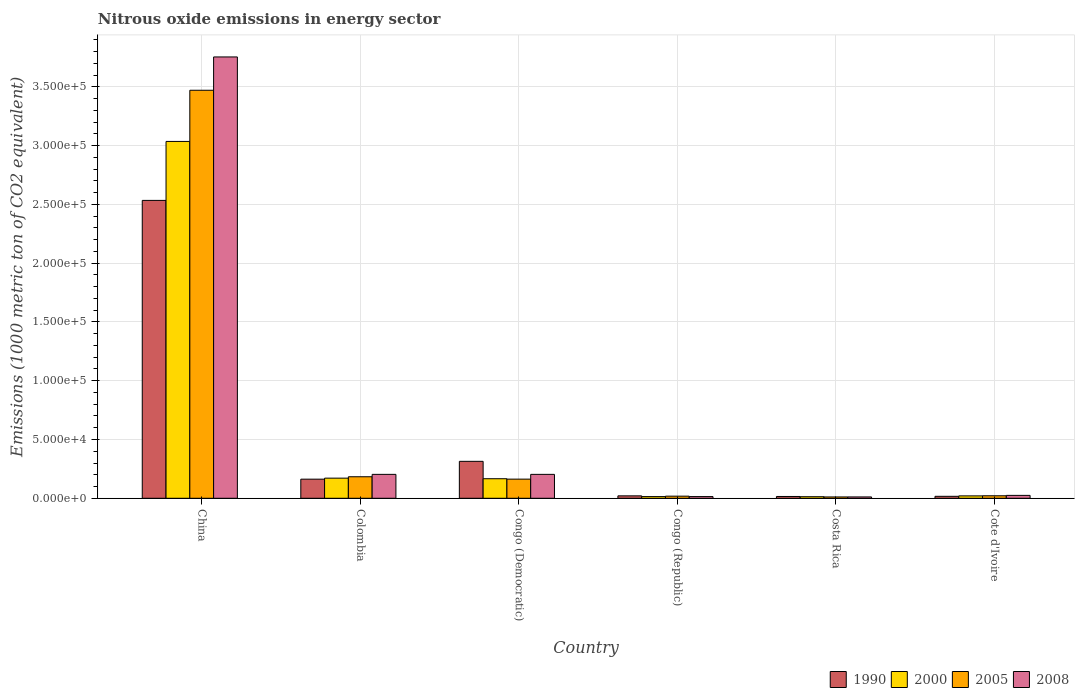How many different coloured bars are there?
Offer a terse response. 4. How many groups of bars are there?
Offer a terse response. 6. Are the number of bars on each tick of the X-axis equal?
Offer a terse response. Yes. How many bars are there on the 3rd tick from the left?
Your answer should be compact. 4. How many bars are there on the 4th tick from the right?
Offer a very short reply. 4. What is the label of the 2nd group of bars from the left?
Provide a short and direct response. Colombia. What is the amount of nitrous oxide emitted in 2000 in Congo (Republic)?
Provide a short and direct response. 1432.4. Across all countries, what is the maximum amount of nitrous oxide emitted in 2008?
Make the answer very short. 3.75e+05. Across all countries, what is the minimum amount of nitrous oxide emitted in 1990?
Make the answer very short. 1535. What is the total amount of nitrous oxide emitted in 1990 in the graph?
Your response must be concise. 3.06e+05. What is the difference between the amount of nitrous oxide emitted in 2005 in China and that in Costa Rica?
Keep it short and to the point. 3.46e+05. What is the difference between the amount of nitrous oxide emitted in 2005 in China and the amount of nitrous oxide emitted in 2000 in Costa Rica?
Ensure brevity in your answer.  3.46e+05. What is the average amount of nitrous oxide emitted in 1990 per country?
Your answer should be compact. 5.11e+04. What is the difference between the amount of nitrous oxide emitted of/in 2000 and amount of nitrous oxide emitted of/in 1990 in Colombia?
Provide a short and direct response. 864.4. In how many countries, is the amount of nitrous oxide emitted in 1990 greater than 130000 1000 metric ton?
Your answer should be compact. 1. What is the ratio of the amount of nitrous oxide emitted in 2008 in China to that in Colombia?
Ensure brevity in your answer.  18.46. What is the difference between the highest and the second highest amount of nitrous oxide emitted in 1990?
Your answer should be very brief. 2.22e+05. What is the difference between the highest and the lowest amount of nitrous oxide emitted in 2000?
Provide a short and direct response. 3.02e+05. Is it the case that in every country, the sum of the amount of nitrous oxide emitted in 2005 and amount of nitrous oxide emitted in 1990 is greater than the sum of amount of nitrous oxide emitted in 2008 and amount of nitrous oxide emitted in 2000?
Provide a short and direct response. No. How many bars are there?
Provide a short and direct response. 24. How many countries are there in the graph?
Ensure brevity in your answer.  6. Does the graph contain any zero values?
Your answer should be compact. No. How are the legend labels stacked?
Offer a very short reply. Horizontal. What is the title of the graph?
Provide a succinct answer. Nitrous oxide emissions in energy sector. What is the label or title of the X-axis?
Provide a short and direct response. Country. What is the label or title of the Y-axis?
Ensure brevity in your answer.  Emissions (1000 metric ton of CO2 equivalent). What is the Emissions (1000 metric ton of CO2 equivalent) of 1990 in China?
Offer a terse response. 2.53e+05. What is the Emissions (1000 metric ton of CO2 equivalent) of 2000 in China?
Ensure brevity in your answer.  3.04e+05. What is the Emissions (1000 metric ton of CO2 equivalent) of 2005 in China?
Make the answer very short. 3.47e+05. What is the Emissions (1000 metric ton of CO2 equivalent) in 2008 in China?
Provide a short and direct response. 3.75e+05. What is the Emissions (1000 metric ton of CO2 equivalent) of 1990 in Colombia?
Give a very brief answer. 1.63e+04. What is the Emissions (1000 metric ton of CO2 equivalent) of 2000 in Colombia?
Your answer should be very brief. 1.71e+04. What is the Emissions (1000 metric ton of CO2 equivalent) in 2005 in Colombia?
Offer a terse response. 1.83e+04. What is the Emissions (1000 metric ton of CO2 equivalent) of 2008 in Colombia?
Keep it short and to the point. 2.03e+04. What is the Emissions (1000 metric ton of CO2 equivalent) of 1990 in Congo (Democratic)?
Your response must be concise. 3.14e+04. What is the Emissions (1000 metric ton of CO2 equivalent) of 2000 in Congo (Democratic)?
Make the answer very short. 1.66e+04. What is the Emissions (1000 metric ton of CO2 equivalent) of 2005 in Congo (Democratic)?
Your response must be concise. 1.63e+04. What is the Emissions (1000 metric ton of CO2 equivalent) of 2008 in Congo (Democratic)?
Keep it short and to the point. 2.03e+04. What is the Emissions (1000 metric ton of CO2 equivalent) of 1990 in Congo (Republic)?
Provide a succinct answer. 2061.2. What is the Emissions (1000 metric ton of CO2 equivalent) in 2000 in Congo (Republic)?
Keep it short and to the point. 1432.4. What is the Emissions (1000 metric ton of CO2 equivalent) of 2005 in Congo (Republic)?
Your answer should be very brief. 1806.4. What is the Emissions (1000 metric ton of CO2 equivalent) of 2008 in Congo (Republic)?
Provide a short and direct response. 1443.1. What is the Emissions (1000 metric ton of CO2 equivalent) in 1990 in Costa Rica?
Provide a short and direct response. 1535. What is the Emissions (1000 metric ton of CO2 equivalent) in 2000 in Costa Rica?
Offer a terse response. 1331.8. What is the Emissions (1000 metric ton of CO2 equivalent) of 2005 in Costa Rica?
Ensure brevity in your answer.  1138.2. What is the Emissions (1000 metric ton of CO2 equivalent) of 2008 in Costa Rica?
Keep it short and to the point. 1145.2. What is the Emissions (1000 metric ton of CO2 equivalent) in 1990 in Cote d'Ivoire?
Provide a succinct answer. 1664.9. What is the Emissions (1000 metric ton of CO2 equivalent) of 2000 in Cote d'Ivoire?
Ensure brevity in your answer.  2041.8. What is the Emissions (1000 metric ton of CO2 equivalent) in 2005 in Cote d'Ivoire?
Keep it short and to the point. 2128.3. What is the Emissions (1000 metric ton of CO2 equivalent) in 2008 in Cote d'Ivoire?
Ensure brevity in your answer.  2465.6. Across all countries, what is the maximum Emissions (1000 metric ton of CO2 equivalent) in 1990?
Keep it short and to the point. 2.53e+05. Across all countries, what is the maximum Emissions (1000 metric ton of CO2 equivalent) of 2000?
Offer a very short reply. 3.04e+05. Across all countries, what is the maximum Emissions (1000 metric ton of CO2 equivalent) of 2005?
Your answer should be very brief. 3.47e+05. Across all countries, what is the maximum Emissions (1000 metric ton of CO2 equivalent) of 2008?
Provide a succinct answer. 3.75e+05. Across all countries, what is the minimum Emissions (1000 metric ton of CO2 equivalent) in 1990?
Ensure brevity in your answer.  1535. Across all countries, what is the minimum Emissions (1000 metric ton of CO2 equivalent) of 2000?
Provide a succinct answer. 1331.8. Across all countries, what is the minimum Emissions (1000 metric ton of CO2 equivalent) in 2005?
Keep it short and to the point. 1138.2. Across all countries, what is the minimum Emissions (1000 metric ton of CO2 equivalent) of 2008?
Your response must be concise. 1145.2. What is the total Emissions (1000 metric ton of CO2 equivalent) of 1990 in the graph?
Your answer should be very brief. 3.06e+05. What is the total Emissions (1000 metric ton of CO2 equivalent) of 2000 in the graph?
Your answer should be compact. 3.42e+05. What is the total Emissions (1000 metric ton of CO2 equivalent) in 2005 in the graph?
Provide a short and direct response. 3.87e+05. What is the total Emissions (1000 metric ton of CO2 equivalent) in 2008 in the graph?
Your answer should be compact. 4.21e+05. What is the difference between the Emissions (1000 metric ton of CO2 equivalent) of 1990 in China and that in Colombia?
Offer a terse response. 2.37e+05. What is the difference between the Emissions (1000 metric ton of CO2 equivalent) in 2000 in China and that in Colombia?
Your response must be concise. 2.86e+05. What is the difference between the Emissions (1000 metric ton of CO2 equivalent) in 2005 in China and that in Colombia?
Your answer should be compact. 3.29e+05. What is the difference between the Emissions (1000 metric ton of CO2 equivalent) in 2008 in China and that in Colombia?
Ensure brevity in your answer.  3.55e+05. What is the difference between the Emissions (1000 metric ton of CO2 equivalent) of 1990 in China and that in Congo (Democratic)?
Your response must be concise. 2.22e+05. What is the difference between the Emissions (1000 metric ton of CO2 equivalent) of 2000 in China and that in Congo (Democratic)?
Ensure brevity in your answer.  2.87e+05. What is the difference between the Emissions (1000 metric ton of CO2 equivalent) of 2005 in China and that in Congo (Democratic)?
Make the answer very short. 3.31e+05. What is the difference between the Emissions (1000 metric ton of CO2 equivalent) of 2008 in China and that in Congo (Democratic)?
Your answer should be very brief. 3.55e+05. What is the difference between the Emissions (1000 metric ton of CO2 equivalent) of 1990 in China and that in Congo (Republic)?
Your response must be concise. 2.51e+05. What is the difference between the Emissions (1000 metric ton of CO2 equivalent) in 2000 in China and that in Congo (Republic)?
Provide a short and direct response. 3.02e+05. What is the difference between the Emissions (1000 metric ton of CO2 equivalent) in 2005 in China and that in Congo (Republic)?
Give a very brief answer. 3.45e+05. What is the difference between the Emissions (1000 metric ton of CO2 equivalent) in 2008 in China and that in Congo (Republic)?
Ensure brevity in your answer.  3.74e+05. What is the difference between the Emissions (1000 metric ton of CO2 equivalent) in 1990 in China and that in Costa Rica?
Provide a short and direct response. 2.52e+05. What is the difference between the Emissions (1000 metric ton of CO2 equivalent) of 2000 in China and that in Costa Rica?
Provide a short and direct response. 3.02e+05. What is the difference between the Emissions (1000 metric ton of CO2 equivalent) in 2005 in China and that in Costa Rica?
Keep it short and to the point. 3.46e+05. What is the difference between the Emissions (1000 metric ton of CO2 equivalent) of 2008 in China and that in Costa Rica?
Your answer should be compact. 3.74e+05. What is the difference between the Emissions (1000 metric ton of CO2 equivalent) in 1990 in China and that in Cote d'Ivoire?
Your answer should be compact. 2.52e+05. What is the difference between the Emissions (1000 metric ton of CO2 equivalent) of 2000 in China and that in Cote d'Ivoire?
Keep it short and to the point. 3.02e+05. What is the difference between the Emissions (1000 metric ton of CO2 equivalent) in 2005 in China and that in Cote d'Ivoire?
Offer a terse response. 3.45e+05. What is the difference between the Emissions (1000 metric ton of CO2 equivalent) in 2008 in China and that in Cote d'Ivoire?
Your answer should be very brief. 3.73e+05. What is the difference between the Emissions (1000 metric ton of CO2 equivalent) in 1990 in Colombia and that in Congo (Democratic)?
Keep it short and to the point. -1.52e+04. What is the difference between the Emissions (1000 metric ton of CO2 equivalent) in 2000 in Colombia and that in Congo (Democratic)?
Keep it short and to the point. 489.3. What is the difference between the Emissions (1000 metric ton of CO2 equivalent) of 2005 in Colombia and that in Congo (Democratic)?
Keep it short and to the point. 2014.7. What is the difference between the Emissions (1000 metric ton of CO2 equivalent) of 1990 in Colombia and that in Congo (Republic)?
Your answer should be very brief. 1.42e+04. What is the difference between the Emissions (1000 metric ton of CO2 equivalent) in 2000 in Colombia and that in Congo (Republic)?
Keep it short and to the point. 1.57e+04. What is the difference between the Emissions (1000 metric ton of CO2 equivalent) in 2005 in Colombia and that in Congo (Republic)?
Offer a terse response. 1.65e+04. What is the difference between the Emissions (1000 metric ton of CO2 equivalent) in 2008 in Colombia and that in Congo (Republic)?
Offer a very short reply. 1.89e+04. What is the difference between the Emissions (1000 metric ton of CO2 equivalent) of 1990 in Colombia and that in Costa Rica?
Provide a short and direct response. 1.47e+04. What is the difference between the Emissions (1000 metric ton of CO2 equivalent) in 2000 in Colombia and that in Costa Rica?
Your answer should be very brief. 1.58e+04. What is the difference between the Emissions (1000 metric ton of CO2 equivalent) in 2005 in Colombia and that in Costa Rica?
Offer a terse response. 1.72e+04. What is the difference between the Emissions (1000 metric ton of CO2 equivalent) in 2008 in Colombia and that in Costa Rica?
Provide a succinct answer. 1.92e+04. What is the difference between the Emissions (1000 metric ton of CO2 equivalent) in 1990 in Colombia and that in Cote d'Ivoire?
Make the answer very short. 1.46e+04. What is the difference between the Emissions (1000 metric ton of CO2 equivalent) of 2000 in Colombia and that in Cote d'Ivoire?
Your answer should be compact. 1.51e+04. What is the difference between the Emissions (1000 metric ton of CO2 equivalent) in 2005 in Colombia and that in Cote d'Ivoire?
Make the answer very short. 1.62e+04. What is the difference between the Emissions (1000 metric ton of CO2 equivalent) in 2008 in Colombia and that in Cote d'Ivoire?
Ensure brevity in your answer.  1.79e+04. What is the difference between the Emissions (1000 metric ton of CO2 equivalent) in 1990 in Congo (Democratic) and that in Congo (Republic)?
Provide a succinct answer. 2.94e+04. What is the difference between the Emissions (1000 metric ton of CO2 equivalent) of 2000 in Congo (Democratic) and that in Congo (Republic)?
Make the answer very short. 1.52e+04. What is the difference between the Emissions (1000 metric ton of CO2 equivalent) in 2005 in Congo (Democratic) and that in Congo (Republic)?
Your answer should be very brief. 1.45e+04. What is the difference between the Emissions (1000 metric ton of CO2 equivalent) of 2008 in Congo (Democratic) and that in Congo (Republic)?
Provide a succinct answer. 1.89e+04. What is the difference between the Emissions (1000 metric ton of CO2 equivalent) in 1990 in Congo (Democratic) and that in Costa Rica?
Give a very brief answer. 2.99e+04. What is the difference between the Emissions (1000 metric ton of CO2 equivalent) in 2000 in Congo (Democratic) and that in Costa Rica?
Your response must be concise. 1.53e+04. What is the difference between the Emissions (1000 metric ton of CO2 equivalent) of 2005 in Congo (Democratic) and that in Costa Rica?
Ensure brevity in your answer.  1.52e+04. What is the difference between the Emissions (1000 metric ton of CO2 equivalent) in 2008 in Congo (Democratic) and that in Costa Rica?
Keep it short and to the point. 1.92e+04. What is the difference between the Emissions (1000 metric ton of CO2 equivalent) of 1990 in Congo (Democratic) and that in Cote d'Ivoire?
Your answer should be very brief. 2.98e+04. What is the difference between the Emissions (1000 metric ton of CO2 equivalent) of 2000 in Congo (Democratic) and that in Cote d'Ivoire?
Offer a very short reply. 1.46e+04. What is the difference between the Emissions (1000 metric ton of CO2 equivalent) of 2005 in Congo (Democratic) and that in Cote d'Ivoire?
Keep it short and to the point. 1.42e+04. What is the difference between the Emissions (1000 metric ton of CO2 equivalent) in 2008 in Congo (Democratic) and that in Cote d'Ivoire?
Your answer should be very brief. 1.79e+04. What is the difference between the Emissions (1000 metric ton of CO2 equivalent) in 1990 in Congo (Republic) and that in Costa Rica?
Provide a succinct answer. 526.2. What is the difference between the Emissions (1000 metric ton of CO2 equivalent) in 2000 in Congo (Republic) and that in Costa Rica?
Your answer should be compact. 100.6. What is the difference between the Emissions (1000 metric ton of CO2 equivalent) in 2005 in Congo (Republic) and that in Costa Rica?
Keep it short and to the point. 668.2. What is the difference between the Emissions (1000 metric ton of CO2 equivalent) in 2008 in Congo (Republic) and that in Costa Rica?
Provide a short and direct response. 297.9. What is the difference between the Emissions (1000 metric ton of CO2 equivalent) in 1990 in Congo (Republic) and that in Cote d'Ivoire?
Offer a very short reply. 396.3. What is the difference between the Emissions (1000 metric ton of CO2 equivalent) in 2000 in Congo (Republic) and that in Cote d'Ivoire?
Provide a short and direct response. -609.4. What is the difference between the Emissions (1000 metric ton of CO2 equivalent) of 2005 in Congo (Republic) and that in Cote d'Ivoire?
Keep it short and to the point. -321.9. What is the difference between the Emissions (1000 metric ton of CO2 equivalent) of 2008 in Congo (Republic) and that in Cote d'Ivoire?
Provide a short and direct response. -1022.5. What is the difference between the Emissions (1000 metric ton of CO2 equivalent) in 1990 in Costa Rica and that in Cote d'Ivoire?
Provide a short and direct response. -129.9. What is the difference between the Emissions (1000 metric ton of CO2 equivalent) in 2000 in Costa Rica and that in Cote d'Ivoire?
Keep it short and to the point. -710. What is the difference between the Emissions (1000 metric ton of CO2 equivalent) of 2005 in Costa Rica and that in Cote d'Ivoire?
Provide a succinct answer. -990.1. What is the difference between the Emissions (1000 metric ton of CO2 equivalent) of 2008 in Costa Rica and that in Cote d'Ivoire?
Offer a terse response. -1320.4. What is the difference between the Emissions (1000 metric ton of CO2 equivalent) of 1990 in China and the Emissions (1000 metric ton of CO2 equivalent) of 2000 in Colombia?
Provide a succinct answer. 2.36e+05. What is the difference between the Emissions (1000 metric ton of CO2 equivalent) of 1990 in China and the Emissions (1000 metric ton of CO2 equivalent) of 2005 in Colombia?
Offer a very short reply. 2.35e+05. What is the difference between the Emissions (1000 metric ton of CO2 equivalent) of 1990 in China and the Emissions (1000 metric ton of CO2 equivalent) of 2008 in Colombia?
Offer a very short reply. 2.33e+05. What is the difference between the Emissions (1000 metric ton of CO2 equivalent) of 2000 in China and the Emissions (1000 metric ton of CO2 equivalent) of 2005 in Colombia?
Make the answer very short. 2.85e+05. What is the difference between the Emissions (1000 metric ton of CO2 equivalent) of 2000 in China and the Emissions (1000 metric ton of CO2 equivalent) of 2008 in Colombia?
Offer a terse response. 2.83e+05. What is the difference between the Emissions (1000 metric ton of CO2 equivalent) of 2005 in China and the Emissions (1000 metric ton of CO2 equivalent) of 2008 in Colombia?
Your response must be concise. 3.27e+05. What is the difference between the Emissions (1000 metric ton of CO2 equivalent) in 1990 in China and the Emissions (1000 metric ton of CO2 equivalent) in 2000 in Congo (Democratic)?
Your answer should be compact. 2.37e+05. What is the difference between the Emissions (1000 metric ton of CO2 equivalent) of 1990 in China and the Emissions (1000 metric ton of CO2 equivalent) of 2005 in Congo (Democratic)?
Keep it short and to the point. 2.37e+05. What is the difference between the Emissions (1000 metric ton of CO2 equivalent) in 1990 in China and the Emissions (1000 metric ton of CO2 equivalent) in 2008 in Congo (Democratic)?
Offer a very short reply. 2.33e+05. What is the difference between the Emissions (1000 metric ton of CO2 equivalent) of 2000 in China and the Emissions (1000 metric ton of CO2 equivalent) of 2005 in Congo (Democratic)?
Provide a short and direct response. 2.87e+05. What is the difference between the Emissions (1000 metric ton of CO2 equivalent) of 2000 in China and the Emissions (1000 metric ton of CO2 equivalent) of 2008 in Congo (Democratic)?
Ensure brevity in your answer.  2.83e+05. What is the difference between the Emissions (1000 metric ton of CO2 equivalent) of 2005 in China and the Emissions (1000 metric ton of CO2 equivalent) of 2008 in Congo (Democratic)?
Your response must be concise. 3.27e+05. What is the difference between the Emissions (1000 metric ton of CO2 equivalent) in 1990 in China and the Emissions (1000 metric ton of CO2 equivalent) in 2000 in Congo (Republic)?
Your answer should be very brief. 2.52e+05. What is the difference between the Emissions (1000 metric ton of CO2 equivalent) of 1990 in China and the Emissions (1000 metric ton of CO2 equivalent) of 2005 in Congo (Republic)?
Provide a succinct answer. 2.52e+05. What is the difference between the Emissions (1000 metric ton of CO2 equivalent) of 1990 in China and the Emissions (1000 metric ton of CO2 equivalent) of 2008 in Congo (Republic)?
Offer a terse response. 2.52e+05. What is the difference between the Emissions (1000 metric ton of CO2 equivalent) of 2000 in China and the Emissions (1000 metric ton of CO2 equivalent) of 2005 in Congo (Republic)?
Your answer should be very brief. 3.02e+05. What is the difference between the Emissions (1000 metric ton of CO2 equivalent) of 2000 in China and the Emissions (1000 metric ton of CO2 equivalent) of 2008 in Congo (Republic)?
Provide a short and direct response. 3.02e+05. What is the difference between the Emissions (1000 metric ton of CO2 equivalent) of 2005 in China and the Emissions (1000 metric ton of CO2 equivalent) of 2008 in Congo (Republic)?
Keep it short and to the point. 3.46e+05. What is the difference between the Emissions (1000 metric ton of CO2 equivalent) of 1990 in China and the Emissions (1000 metric ton of CO2 equivalent) of 2000 in Costa Rica?
Make the answer very short. 2.52e+05. What is the difference between the Emissions (1000 metric ton of CO2 equivalent) in 1990 in China and the Emissions (1000 metric ton of CO2 equivalent) in 2005 in Costa Rica?
Your answer should be compact. 2.52e+05. What is the difference between the Emissions (1000 metric ton of CO2 equivalent) in 1990 in China and the Emissions (1000 metric ton of CO2 equivalent) in 2008 in Costa Rica?
Your answer should be very brief. 2.52e+05. What is the difference between the Emissions (1000 metric ton of CO2 equivalent) in 2000 in China and the Emissions (1000 metric ton of CO2 equivalent) in 2005 in Costa Rica?
Give a very brief answer. 3.02e+05. What is the difference between the Emissions (1000 metric ton of CO2 equivalent) in 2000 in China and the Emissions (1000 metric ton of CO2 equivalent) in 2008 in Costa Rica?
Your response must be concise. 3.02e+05. What is the difference between the Emissions (1000 metric ton of CO2 equivalent) in 2005 in China and the Emissions (1000 metric ton of CO2 equivalent) in 2008 in Costa Rica?
Ensure brevity in your answer.  3.46e+05. What is the difference between the Emissions (1000 metric ton of CO2 equivalent) of 1990 in China and the Emissions (1000 metric ton of CO2 equivalent) of 2000 in Cote d'Ivoire?
Keep it short and to the point. 2.51e+05. What is the difference between the Emissions (1000 metric ton of CO2 equivalent) in 1990 in China and the Emissions (1000 metric ton of CO2 equivalent) in 2005 in Cote d'Ivoire?
Provide a succinct answer. 2.51e+05. What is the difference between the Emissions (1000 metric ton of CO2 equivalent) of 1990 in China and the Emissions (1000 metric ton of CO2 equivalent) of 2008 in Cote d'Ivoire?
Give a very brief answer. 2.51e+05. What is the difference between the Emissions (1000 metric ton of CO2 equivalent) in 2000 in China and the Emissions (1000 metric ton of CO2 equivalent) in 2005 in Cote d'Ivoire?
Make the answer very short. 3.01e+05. What is the difference between the Emissions (1000 metric ton of CO2 equivalent) in 2000 in China and the Emissions (1000 metric ton of CO2 equivalent) in 2008 in Cote d'Ivoire?
Ensure brevity in your answer.  3.01e+05. What is the difference between the Emissions (1000 metric ton of CO2 equivalent) in 2005 in China and the Emissions (1000 metric ton of CO2 equivalent) in 2008 in Cote d'Ivoire?
Your answer should be compact. 3.45e+05. What is the difference between the Emissions (1000 metric ton of CO2 equivalent) of 1990 in Colombia and the Emissions (1000 metric ton of CO2 equivalent) of 2000 in Congo (Democratic)?
Offer a very short reply. -375.1. What is the difference between the Emissions (1000 metric ton of CO2 equivalent) in 1990 in Colombia and the Emissions (1000 metric ton of CO2 equivalent) in 2005 in Congo (Democratic)?
Make the answer very short. -32.9. What is the difference between the Emissions (1000 metric ton of CO2 equivalent) in 1990 in Colombia and the Emissions (1000 metric ton of CO2 equivalent) in 2008 in Congo (Democratic)?
Offer a very short reply. -4075.6. What is the difference between the Emissions (1000 metric ton of CO2 equivalent) in 2000 in Colombia and the Emissions (1000 metric ton of CO2 equivalent) in 2005 in Congo (Democratic)?
Your answer should be very brief. 831.5. What is the difference between the Emissions (1000 metric ton of CO2 equivalent) in 2000 in Colombia and the Emissions (1000 metric ton of CO2 equivalent) in 2008 in Congo (Democratic)?
Provide a short and direct response. -3211.2. What is the difference between the Emissions (1000 metric ton of CO2 equivalent) in 2005 in Colombia and the Emissions (1000 metric ton of CO2 equivalent) in 2008 in Congo (Democratic)?
Your answer should be compact. -2028. What is the difference between the Emissions (1000 metric ton of CO2 equivalent) of 1990 in Colombia and the Emissions (1000 metric ton of CO2 equivalent) of 2000 in Congo (Republic)?
Provide a short and direct response. 1.48e+04. What is the difference between the Emissions (1000 metric ton of CO2 equivalent) in 1990 in Colombia and the Emissions (1000 metric ton of CO2 equivalent) in 2005 in Congo (Republic)?
Provide a succinct answer. 1.45e+04. What is the difference between the Emissions (1000 metric ton of CO2 equivalent) in 1990 in Colombia and the Emissions (1000 metric ton of CO2 equivalent) in 2008 in Congo (Republic)?
Provide a short and direct response. 1.48e+04. What is the difference between the Emissions (1000 metric ton of CO2 equivalent) of 2000 in Colombia and the Emissions (1000 metric ton of CO2 equivalent) of 2005 in Congo (Republic)?
Provide a short and direct response. 1.53e+04. What is the difference between the Emissions (1000 metric ton of CO2 equivalent) in 2000 in Colombia and the Emissions (1000 metric ton of CO2 equivalent) in 2008 in Congo (Republic)?
Your answer should be very brief. 1.57e+04. What is the difference between the Emissions (1000 metric ton of CO2 equivalent) of 2005 in Colombia and the Emissions (1000 metric ton of CO2 equivalent) of 2008 in Congo (Republic)?
Provide a succinct answer. 1.69e+04. What is the difference between the Emissions (1000 metric ton of CO2 equivalent) in 1990 in Colombia and the Emissions (1000 metric ton of CO2 equivalent) in 2000 in Costa Rica?
Offer a terse response. 1.49e+04. What is the difference between the Emissions (1000 metric ton of CO2 equivalent) in 1990 in Colombia and the Emissions (1000 metric ton of CO2 equivalent) in 2005 in Costa Rica?
Give a very brief answer. 1.51e+04. What is the difference between the Emissions (1000 metric ton of CO2 equivalent) of 1990 in Colombia and the Emissions (1000 metric ton of CO2 equivalent) of 2008 in Costa Rica?
Provide a short and direct response. 1.51e+04. What is the difference between the Emissions (1000 metric ton of CO2 equivalent) of 2000 in Colombia and the Emissions (1000 metric ton of CO2 equivalent) of 2005 in Costa Rica?
Offer a terse response. 1.60e+04. What is the difference between the Emissions (1000 metric ton of CO2 equivalent) in 2000 in Colombia and the Emissions (1000 metric ton of CO2 equivalent) in 2008 in Costa Rica?
Give a very brief answer. 1.60e+04. What is the difference between the Emissions (1000 metric ton of CO2 equivalent) in 2005 in Colombia and the Emissions (1000 metric ton of CO2 equivalent) in 2008 in Costa Rica?
Ensure brevity in your answer.  1.72e+04. What is the difference between the Emissions (1000 metric ton of CO2 equivalent) of 1990 in Colombia and the Emissions (1000 metric ton of CO2 equivalent) of 2000 in Cote d'Ivoire?
Your response must be concise. 1.42e+04. What is the difference between the Emissions (1000 metric ton of CO2 equivalent) of 1990 in Colombia and the Emissions (1000 metric ton of CO2 equivalent) of 2005 in Cote d'Ivoire?
Provide a short and direct response. 1.41e+04. What is the difference between the Emissions (1000 metric ton of CO2 equivalent) of 1990 in Colombia and the Emissions (1000 metric ton of CO2 equivalent) of 2008 in Cote d'Ivoire?
Your answer should be compact. 1.38e+04. What is the difference between the Emissions (1000 metric ton of CO2 equivalent) in 2000 in Colombia and the Emissions (1000 metric ton of CO2 equivalent) in 2005 in Cote d'Ivoire?
Offer a very short reply. 1.50e+04. What is the difference between the Emissions (1000 metric ton of CO2 equivalent) of 2000 in Colombia and the Emissions (1000 metric ton of CO2 equivalent) of 2008 in Cote d'Ivoire?
Provide a short and direct response. 1.47e+04. What is the difference between the Emissions (1000 metric ton of CO2 equivalent) in 2005 in Colombia and the Emissions (1000 metric ton of CO2 equivalent) in 2008 in Cote d'Ivoire?
Give a very brief answer. 1.58e+04. What is the difference between the Emissions (1000 metric ton of CO2 equivalent) in 1990 in Congo (Democratic) and the Emissions (1000 metric ton of CO2 equivalent) in 2000 in Congo (Republic)?
Ensure brevity in your answer.  3.00e+04. What is the difference between the Emissions (1000 metric ton of CO2 equivalent) of 1990 in Congo (Democratic) and the Emissions (1000 metric ton of CO2 equivalent) of 2005 in Congo (Republic)?
Ensure brevity in your answer.  2.96e+04. What is the difference between the Emissions (1000 metric ton of CO2 equivalent) of 1990 in Congo (Democratic) and the Emissions (1000 metric ton of CO2 equivalent) of 2008 in Congo (Republic)?
Provide a short and direct response. 3.00e+04. What is the difference between the Emissions (1000 metric ton of CO2 equivalent) in 2000 in Congo (Democratic) and the Emissions (1000 metric ton of CO2 equivalent) in 2005 in Congo (Republic)?
Provide a succinct answer. 1.48e+04. What is the difference between the Emissions (1000 metric ton of CO2 equivalent) of 2000 in Congo (Democratic) and the Emissions (1000 metric ton of CO2 equivalent) of 2008 in Congo (Republic)?
Give a very brief answer. 1.52e+04. What is the difference between the Emissions (1000 metric ton of CO2 equivalent) in 2005 in Congo (Democratic) and the Emissions (1000 metric ton of CO2 equivalent) in 2008 in Congo (Republic)?
Offer a terse response. 1.49e+04. What is the difference between the Emissions (1000 metric ton of CO2 equivalent) of 1990 in Congo (Democratic) and the Emissions (1000 metric ton of CO2 equivalent) of 2000 in Costa Rica?
Your answer should be very brief. 3.01e+04. What is the difference between the Emissions (1000 metric ton of CO2 equivalent) in 1990 in Congo (Democratic) and the Emissions (1000 metric ton of CO2 equivalent) in 2005 in Costa Rica?
Make the answer very short. 3.03e+04. What is the difference between the Emissions (1000 metric ton of CO2 equivalent) in 1990 in Congo (Democratic) and the Emissions (1000 metric ton of CO2 equivalent) in 2008 in Costa Rica?
Your answer should be compact. 3.03e+04. What is the difference between the Emissions (1000 metric ton of CO2 equivalent) in 2000 in Congo (Democratic) and the Emissions (1000 metric ton of CO2 equivalent) in 2005 in Costa Rica?
Provide a succinct answer. 1.55e+04. What is the difference between the Emissions (1000 metric ton of CO2 equivalent) in 2000 in Congo (Democratic) and the Emissions (1000 metric ton of CO2 equivalent) in 2008 in Costa Rica?
Make the answer very short. 1.55e+04. What is the difference between the Emissions (1000 metric ton of CO2 equivalent) of 2005 in Congo (Democratic) and the Emissions (1000 metric ton of CO2 equivalent) of 2008 in Costa Rica?
Make the answer very short. 1.51e+04. What is the difference between the Emissions (1000 metric ton of CO2 equivalent) in 1990 in Congo (Democratic) and the Emissions (1000 metric ton of CO2 equivalent) in 2000 in Cote d'Ivoire?
Offer a very short reply. 2.94e+04. What is the difference between the Emissions (1000 metric ton of CO2 equivalent) in 1990 in Congo (Democratic) and the Emissions (1000 metric ton of CO2 equivalent) in 2005 in Cote d'Ivoire?
Give a very brief answer. 2.93e+04. What is the difference between the Emissions (1000 metric ton of CO2 equivalent) in 1990 in Congo (Democratic) and the Emissions (1000 metric ton of CO2 equivalent) in 2008 in Cote d'Ivoire?
Your answer should be compact. 2.90e+04. What is the difference between the Emissions (1000 metric ton of CO2 equivalent) of 2000 in Congo (Democratic) and the Emissions (1000 metric ton of CO2 equivalent) of 2005 in Cote d'Ivoire?
Provide a succinct answer. 1.45e+04. What is the difference between the Emissions (1000 metric ton of CO2 equivalent) in 2000 in Congo (Democratic) and the Emissions (1000 metric ton of CO2 equivalent) in 2008 in Cote d'Ivoire?
Provide a short and direct response. 1.42e+04. What is the difference between the Emissions (1000 metric ton of CO2 equivalent) of 2005 in Congo (Democratic) and the Emissions (1000 metric ton of CO2 equivalent) of 2008 in Cote d'Ivoire?
Make the answer very short. 1.38e+04. What is the difference between the Emissions (1000 metric ton of CO2 equivalent) in 1990 in Congo (Republic) and the Emissions (1000 metric ton of CO2 equivalent) in 2000 in Costa Rica?
Provide a short and direct response. 729.4. What is the difference between the Emissions (1000 metric ton of CO2 equivalent) of 1990 in Congo (Republic) and the Emissions (1000 metric ton of CO2 equivalent) of 2005 in Costa Rica?
Provide a succinct answer. 923. What is the difference between the Emissions (1000 metric ton of CO2 equivalent) in 1990 in Congo (Republic) and the Emissions (1000 metric ton of CO2 equivalent) in 2008 in Costa Rica?
Provide a short and direct response. 916. What is the difference between the Emissions (1000 metric ton of CO2 equivalent) in 2000 in Congo (Republic) and the Emissions (1000 metric ton of CO2 equivalent) in 2005 in Costa Rica?
Your answer should be compact. 294.2. What is the difference between the Emissions (1000 metric ton of CO2 equivalent) of 2000 in Congo (Republic) and the Emissions (1000 metric ton of CO2 equivalent) of 2008 in Costa Rica?
Keep it short and to the point. 287.2. What is the difference between the Emissions (1000 metric ton of CO2 equivalent) in 2005 in Congo (Republic) and the Emissions (1000 metric ton of CO2 equivalent) in 2008 in Costa Rica?
Give a very brief answer. 661.2. What is the difference between the Emissions (1000 metric ton of CO2 equivalent) of 1990 in Congo (Republic) and the Emissions (1000 metric ton of CO2 equivalent) of 2000 in Cote d'Ivoire?
Your answer should be compact. 19.4. What is the difference between the Emissions (1000 metric ton of CO2 equivalent) in 1990 in Congo (Republic) and the Emissions (1000 metric ton of CO2 equivalent) in 2005 in Cote d'Ivoire?
Ensure brevity in your answer.  -67.1. What is the difference between the Emissions (1000 metric ton of CO2 equivalent) in 1990 in Congo (Republic) and the Emissions (1000 metric ton of CO2 equivalent) in 2008 in Cote d'Ivoire?
Give a very brief answer. -404.4. What is the difference between the Emissions (1000 metric ton of CO2 equivalent) of 2000 in Congo (Republic) and the Emissions (1000 metric ton of CO2 equivalent) of 2005 in Cote d'Ivoire?
Provide a succinct answer. -695.9. What is the difference between the Emissions (1000 metric ton of CO2 equivalent) of 2000 in Congo (Republic) and the Emissions (1000 metric ton of CO2 equivalent) of 2008 in Cote d'Ivoire?
Your answer should be very brief. -1033.2. What is the difference between the Emissions (1000 metric ton of CO2 equivalent) in 2005 in Congo (Republic) and the Emissions (1000 metric ton of CO2 equivalent) in 2008 in Cote d'Ivoire?
Keep it short and to the point. -659.2. What is the difference between the Emissions (1000 metric ton of CO2 equivalent) in 1990 in Costa Rica and the Emissions (1000 metric ton of CO2 equivalent) in 2000 in Cote d'Ivoire?
Make the answer very short. -506.8. What is the difference between the Emissions (1000 metric ton of CO2 equivalent) of 1990 in Costa Rica and the Emissions (1000 metric ton of CO2 equivalent) of 2005 in Cote d'Ivoire?
Provide a short and direct response. -593.3. What is the difference between the Emissions (1000 metric ton of CO2 equivalent) of 1990 in Costa Rica and the Emissions (1000 metric ton of CO2 equivalent) of 2008 in Cote d'Ivoire?
Your response must be concise. -930.6. What is the difference between the Emissions (1000 metric ton of CO2 equivalent) in 2000 in Costa Rica and the Emissions (1000 metric ton of CO2 equivalent) in 2005 in Cote d'Ivoire?
Make the answer very short. -796.5. What is the difference between the Emissions (1000 metric ton of CO2 equivalent) in 2000 in Costa Rica and the Emissions (1000 metric ton of CO2 equivalent) in 2008 in Cote d'Ivoire?
Offer a terse response. -1133.8. What is the difference between the Emissions (1000 metric ton of CO2 equivalent) in 2005 in Costa Rica and the Emissions (1000 metric ton of CO2 equivalent) in 2008 in Cote d'Ivoire?
Provide a succinct answer. -1327.4. What is the average Emissions (1000 metric ton of CO2 equivalent) in 1990 per country?
Your response must be concise. 5.11e+04. What is the average Emissions (1000 metric ton of CO2 equivalent) in 2000 per country?
Give a very brief answer. 5.70e+04. What is the average Emissions (1000 metric ton of CO2 equivalent) in 2005 per country?
Keep it short and to the point. 6.45e+04. What is the average Emissions (1000 metric ton of CO2 equivalent) of 2008 per country?
Your response must be concise. 7.02e+04. What is the difference between the Emissions (1000 metric ton of CO2 equivalent) of 1990 and Emissions (1000 metric ton of CO2 equivalent) of 2000 in China?
Offer a terse response. -5.02e+04. What is the difference between the Emissions (1000 metric ton of CO2 equivalent) of 1990 and Emissions (1000 metric ton of CO2 equivalent) of 2005 in China?
Your answer should be compact. -9.37e+04. What is the difference between the Emissions (1000 metric ton of CO2 equivalent) of 1990 and Emissions (1000 metric ton of CO2 equivalent) of 2008 in China?
Provide a succinct answer. -1.22e+05. What is the difference between the Emissions (1000 metric ton of CO2 equivalent) of 2000 and Emissions (1000 metric ton of CO2 equivalent) of 2005 in China?
Keep it short and to the point. -4.35e+04. What is the difference between the Emissions (1000 metric ton of CO2 equivalent) in 2000 and Emissions (1000 metric ton of CO2 equivalent) in 2008 in China?
Your answer should be very brief. -7.19e+04. What is the difference between the Emissions (1000 metric ton of CO2 equivalent) of 2005 and Emissions (1000 metric ton of CO2 equivalent) of 2008 in China?
Keep it short and to the point. -2.83e+04. What is the difference between the Emissions (1000 metric ton of CO2 equivalent) of 1990 and Emissions (1000 metric ton of CO2 equivalent) of 2000 in Colombia?
Make the answer very short. -864.4. What is the difference between the Emissions (1000 metric ton of CO2 equivalent) of 1990 and Emissions (1000 metric ton of CO2 equivalent) of 2005 in Colombia?
Offer a very short reply. -2047.6. What is the difference between the Emissions (1000 metric ton of CO2 equivalent) of 1990 and Emissions (1000 metric ton of CO2 equivalent) of 2008 in Colombia?
Offer a very short reply. -4077.5. What is the difference between the Emissions (1000 metric ton of CO2 equivalent) in 2000 and Emissions (1000 metric ton of CO2 equivalent) in 2005 in Colombia?
Provide a succinct answer. -1183.2. What is the difference between the Emissions (1000 metric ton of CO2 equivalent) in 2000 and Emissions (1000 metric ton of CO2 equivalent) in 2008 in Colombia?
Your answer should be very brief. -3213.1. What is the difference between the Emissions (1000 metric ton of CO2 equivalent) of 2005 and Emissions (1000 metric ton of CO2 equivalent) of 2008 in Colombia?
Ensure brevity in your answer.  -2029.9. What is the difference between the Emissions (1000 metric ton of CO2 equivalent) in 1990 and Emissions (1000 metric ton of CO2 equivalent) in 2000 in Congo (Democratic)?
Give a very brief answer. 1.48e+04. What is the difference between the Emissions (1000 metric ton of CO2 equivalent) of 1990 and Emissions (1000 metric ton of CO2 equivalent) of 2005 in Congo (Democratic)?
Provide a short and direct response. 1.51e+04. What is the difference between the Emissions (1000 metric ton of CO2 equivalent) in 1990 and Emissions (1000 metric ton of CO2 equivalent) in 2008 in Congo (Democratic)?
Offer a very short reply. 1.11e+04. What is the difference between the Emissions (1000 metric ton of CO2 equivalent) of 2000 and Emissions (1000 metric ton of CO2 equivalent) of 2005 in Congo (Democratic)?
Provide a succinct answer. 342.2. What is the difference between the Emissions (1000 metric ton of CO2 equivalent) of 2000 and Emissions (1000 metric ton of CO2 equivalent) of 2008 in Congo (Democratic)?
Offer a very short reply. -3700.5. What is the difference between the Emissions (1000 metric ton of CO2 equivalent) in 2005 and Emissions (1000 metric ton of CO2 equivalent) in 2008 in Congo (Democratic)?
Offer a terse response. -4042.7. What is the difference between the Emissions (1000 metric ton of CO2 equivalent) in 1990 and Emissions (1000 metric ton of CO2 equivalent) in 2000 in Congo (Republic)?
Offer a very short reply. 628.8. What is the difference between the Emissions (1000 metric ton of CO2 equivalent) of 1990 and Emissions (1000 metric ton of CO2 equivalent) of 2005 in Congo (Republic)?
Give a very brief answer. 254.8. What is the difference between the Emissions (1000 metric ton of CO2 equivalent) of 1990 and Emissions (1000 metric ton of CO2 equivalent) of 2008 in Congo (Republic)?
Keep it short and to the point. 618.1. What is the difference between the Emissions (1000 metric ton of CO2 equivalent) in 2000 and Emissions (1000 metric ton of CO2 equivalent) in 2005 in Congo (Republic)?
Your answer should be very brief. -374. What is the difference between the Emissions (1000 metric ton of CO2 equivalent) of 2000 and Emissions (1000 metric ton of CO2 equivalent) of 2008 in Congo (Republic)?
Offer a terse response. -10.7. What is the difference between the Emissions (1000 metric ton of CO2 equivalent) of 2005 and Emissions (1000 metric ton of CO2 equivalent) of 2008 in Congo (Republic)?
Give a very brief answer. 363.3. What is the difference between the Emissions (1000 metric ton of CO2 equivalent) of 1990 and Emissions (1000 metric ton of CO2 equivalent) of 2000 in Costa Rica?
Keep it short and to the point. 203.2. What is the difference between the Emissions (1000 metric ton of CO2 equivalent) of 1990 and Emissions (1000 metric ton of CO2 equivalent) of 2005 in Costa Rica?
Make the answer very short. 396.8. What is the difference between the Emissions (1000 metric ton of CO2 equivalent) of 1990 and Emissions (1000 metric ton of CO2 equivalent) of 2008 in Costa Rica?
Offer a very short reply. 389.8. What is the difference between the Emissions (1000 metric ton of CO2 equivalent) in 2000 and Emissions (1000 metric ton of CO2 equivalent) in 2005 in Costa Rica?
Ensure brevity in your answer.  193.6. What is the difference between the Emissions (1000 metric ton of CO2 equivalent) of 2000 and Emissions (1000 metric ton of CO2 equivalent) of 2008 in Costa Rica?
Provide a short and direct response. 186.6. What is the difference between the Emissions (1000 metric ton of CO2 equivalent) of 2005 and Emissions (1000 metric ton of CO2 equivalent) of 2008 in Costa Rica?
Provide a short and direct response. -7. What is the difference between the Emissions (1000 metric ton of CO2 equivalent) in 1990 and Emissions (1000 metric ton of CO2 equivalent) in 2000 in Cote d'Ivoire?
Ensure brevity in your answer.  -376.9. What is the difference between the Emissions (1000 metric ton of CO2 equivalent) in 1990 and Emissions (1000 metric ton of CO2 equivalent) in 2005 in Cote d'Ivoire?
Give a very brief answer. -463.4. What is the difference between the Emissions (1000 metric ton of CO2 equivalent) of 1990 and Emissions (1000 metric ton of CO2 equivalent) of 2008 in Cote d'Ivoire?
Offer a terse response. -800.7. What is the difference between the Emissions (1000 metric ton of CO2 equivalent) in 2000 and Emissions (1000 metric ton of CO2 equivalent) in 2005 in Cote d'Ivoire?
Your answer should be very brief. -86.5. What is the difference between the Emissions (1000 metric ton of CO2 equivalent) of 2000 and Emissions (1000 metric ton of CO2 equivalent) of 2008 in Cote d'Ivoire?
Your answer should be compact. -423.8. What is the difference between the Emissions (1000 metric ton of CO2 equivalent) of 2005 and Emissions (1000 metric ton of CO2 equivalent) of 2008 in Cote d'Ivoire?
Provide a succinct answer. -337.3. What is the ratio of the Emissions (1000 metric ton of CO2 equivalent) in 1990 in China to that in Colombia?
Provide a succinct answer. 15.58. What is the ratio of the Emissions (1000 metric ton of CO2 equivalent) of 2000 in China to that in Colombia?
Give a very brief answer. 17.72. What is the ratio of the Emissions (1000 metric ton of CO2 equivalent) of 2005 in China to that in Colombia?
Your answer should be very brief. 18.96. What is the ratio of the Emissions (1000 metric ton of CO2 equivalent) in 2008 in China to that in Colombia?
Give a very brief answer. 18.46. What is the ratio of the Emissions (1000 metric ton of CO2 equivalent) in 1990 in China to that in Congo (Democratic)?
Keep it short and to the point. 8.06. What is the ratio of the Emissions (1000 metric ton of CO2 equivalent) of 2000 in China to that in Congo (Democratic)?
Provide a short and direct response. 18.25. What is the ratio of the Emissions (1000 metric ton of CO2 equivalent) in 2005 in China to that in Congo (Democratic)?
Provide a succinct answer. 21.3. What is the ratio of the Emissions (1000 metric ton of CO2 equivalent) in 2008 in China to that in Congo (Democratic)?
Provide a succinct answer. 18.46. What is the ratio of the Emissions (1000 metric ton of CO2 equivalent) of 1990 in China to that in Congo (Republic)?
Keep it short and to the point. 122.94. What is the ratio of the Emissions (1000 metric ton of CO2 equivalent) of 2000 in China to that in Congo (Republic)?
Keep it short and to the point. 211.92. What is the ratio of the Emissions (1000 metric ton of CO2 equivalent) in 2005 in China to that in Congo (Republic)?
Make the answer very short. 192.15. What is the ratio of the Emissions (1000 metric ton of CO2 equivalent) of 2008 in China to that in Congo (Republic)?
Provide a short and direct response. 260.16. What is the ratio of the Emissions (1000 metric ton of CO2 equivalent) in 1990 in China to that in Costa Rica?
Give a very brief answer. 165.08. What is the ratio of the Emissions (1000 metric ton of CO2 equivalent) in 2000 in China to that in Costa Rica?
Offer a terse response. 227.93. What is the ratio of the Emissions (1000 metric ton of CO2 equivalent) of 2005 in China to that in Costa Rica?
Your response must be concise. 304.95. What is the ratio of the Emissions (1000 metric ton of CO2 equivalent) of 2008 in China to that in Costa Rica?
Offer a very short reply. 327.83. What is the ratio of the Emissions (1000 metric ton of CO2 equivalent) in 1990 in China to that in Cote d'Ivoire?
Provide a succinct answer. 152.2. What is the ratio of the Emissions (1000 metric ton of CO2 equivalent) of 2000 in China to that in Cote d'Ivoire?
Give a very brief answer. 148.67. What is the ratio of the Emissions (1000 metric ton of CO2 equivalent) of 2005 in China to that in Cote d'Ivoire?
Keep it short and to the point. 163.08. What is the ratio of the Emissions (1000 metric ton of CO2 equivalent) in 2008 in China to that in Cote d'Ivoire?
Your response must be concise. 152.27. What is the ratio of the Emissions (1000 metric ton of CO2 equivalent) of 1990 in Colombia to that in Congo (Democratic)?
Offer a terse response. 0.52. What is the ratio of the Emissions (1000 metric ton of CO2 equivalent) of 2000 in Colombia to that in Congo (Democratic)?
Provide a short and direct response. 1.03. What is the ratio of the Emissions (1000 metric ton of CO2 equivalent) in 2005 in Colombia to that in Congo (Democratic)?
Your answer should be very brief. 1.12. What is the ratio of the Emissions (1000 metric ton of CO2 equivalent) of 2008 in Colombia to that in Congo (Democratic)?
Provide a short and direct response. 1. What is the ratio of the Emissions (1000 metric ton of CO2 equivalent) of 1990 in Colombia to that in Congo (Republic)?
Offer a terse response. 7.89. What is the ratio of the Emissions (1000 metric ton of CO2 equivalent) of 2000 in Colombia to that in Congo (Republic)?
Make the answer very short. 11.96. What is the ratio of the Emissions (1000 metric ton of CO2 equivalent) of 2005 in Colombia to that in Congo (Republic)?
Ensure brevity in your answer.  10.14. What is the ratio of the Emissions (1000 metric ton of CO2 equivalent) of 2008 in Colombia to that in Congo (Republic)?
Keep it short and to the point. 14.09. What is the ratio of the Emissions (1000 metric ton of CO2 equivalent) in 1990 in Colombia to that in Costa Rica?
Make the answer very short. 10.59. What is the ratio of the Emissions (1000 metric ton of CO2 equivalent) of 2000 in Colombia to that in Costa Rica?
Provide a succinct answer. 12.86. What is the ratio of the Emissions (1000 metric ton of CO2 equivalent) in 2005 in Colombia to that in Costa Rica?
Provide a short and direct response. 16.09. What is the ratio of the Emissions (1000 metric ton of CO2 equivalent) of 2008 in Colombia to that in Costa Rica?
Make the answer very short. 17.76. What is the ratio of the Emissions (1000 metric ton of CO2 equivalent) of 1990 in Colombia to that in Cote d'Ivoire?
Your answer should be compact. 9.77. What is the ratio of the Emissions (1000 metric ton of CO2 equivalent) of 2000 in Colombia to that in Cote d'Ivoire?
Offer a very short reply. 8.39. What is the ratio of the Emissions (1000 metric ton of CO2 equivalent) in 2005 in Colombia to that in Cote d'Ivoire?
Provide a short and direct response. 8.6. What is the ratio of the Emissions (1000 metric ton of CO2 equivalent) in 2008 in Colombia to that in Cote d'Ivoire?
Your answer should be compact. 8.25. What is the ratio of the Emissions (1000 metric ton of CO2 equivalent) in 1990 in Congo (Democratic) to that in Congo (Republic)?
Your answer should be compact. 15.25. What is the ratio of the Emissions (1000 metric ton of CO2 equivalent) of 2000 in Congo (Democratic) to that in Congo (Republic)?
Provide a succinct answer. 11.61. What is the ratio of the Emissions (1000 metric ton of CO2 equivalent) in 2005 in Congo (Democratic) to that in Congo (Republic)?
Offer a terse response. 9.02. What is the ratio of the Emissions (1000 metric ton of CO2 equivalent) in 2008 in Congo (Democratic) to that in Congo (Republic)?
Your answer should be very brief. 14.09. What is the ratio of the Emissions (1000 metric ton of CO2 equivalent) of 1990 in Congo (Democratic) to that in Costa Rica?
Provide a short and direct response. 20.48. What is the ratio of the Emissions (1000 metric ton of CO2 equivalent) of 2000 in Congo (Democratic) to that in Costa Rica?
Give a very brief answer. 12.49. What is the ratio of the Emissions (1000 metric ton of CO2 equivalent) of 2005 in Congo (Democratic) to that in Costa Rica?
Keep it short and to the point. 14.32. What is the ratio of the Emissions (1000 metric ton of CO2 equivalent) of 2008 in Congo (Democratic) to that in Costa Rica?
Offer a very short reply. 17.76. What is the ratio of the Emissions (1000 metric ton of CO2 equivalent) in 1990 in Congo (Democratic) to that in Cote d'Ivoire?
Provide a short and direct response. 18.88. What is the ratio of the Emissions (1000 metric ton of CO2 equivalent) in 2000 in Congo (Democratic) to that in Cote d'Ivoire?
Give a very brief answer. 8.15. What is the ratio of the Emissions (1000 metric ton of CO2 equivalent) in 2005 in Congo (Democratic) to that in Cote d'Ivoire?
Provide a succinct answer. 7.66. What is the ratio of the Emissions (1000 metric ton of CO2 equivalent) of 2008 in Congo (Democratic) to that in Cote d'Ivoire?
Provide a short and direct response. 8.25. What is the ratio of the Emissions (1000 metric ton of CO2 equivalent) of 1990 in Congo (Republic) to that in Costa Rica?
Make the answer very short. 1.34. What is the ratio of the Emissions (1000 metric ton of CO2 equivalent) in 2000 in Congo (Republic) to that in Costa Rica?
Provide a short and direct response. 1.08. What is the ratio of the Emissions (1000 metric ton of CO2 equivalent) in 2005 in Congo (Republic) to that in Costa Rica?
Your answer should be very brief. 1.59. What is the ratio of the Emissions (1000 metric ton of CO2 equivalent) of 2008 in Congo (Republic) to that in Costa Rica?
Your response must be concise. 1.26. What is the ratio of the Emissions (1000 metric ton of CO2 equivalent) of 1990 in Congo (Republic) to that in Cote d'Ivoire?
Your answer should be compact. 1.24. What is the ratio of the Emissions (1000 metric ton of CO2 equivalent) in 2000 in Congo (Republic) to that in Cote d'Ivoire?
Provide a short and direct response. 0.7. What is the ratio of the Emissions (1000 metric ton of CO2 equivalent) of 2005 in Congo (Republic) to that in Cote d'Ivoire?
Give a very brief answer. 0.85. What is the ratio of the Emissions (1000 metric ton of CO2 equivalent) in 2008 in Congo (Republic) to that in Cote d'Ivoire?
Offer a very short reply. 0.59. What is the ratio of the Emissions (1000 metric ton of CO2 equivalent) of 1990 in Costa Rica to that in Cote d'Ivoire?
Keep it short and to the point. 0.92. What is the ratio of the Emissions (1000 metric ton of CO2 equivalent) of 2000 in Costa Rica to that in Cote d'Ivoire?
Offer a very short reply. 0.65. What is the ratio of the Emissions (1000 metric ton of CO2 equivalent) in 2005 in Costa Rica to that in Cote d'Ivoire?
Ensure brevity in your answer.  0.53. What is the ratio of the Emissions (1000 metric ton of CO2 equivalent) of 2008 in Costa Rica to that in Cote d'Ivoire?
Provide a succinct answer. 0.46. What is the difference between the highest and the second highest Emissions (1000 metric ton of CO2 equivalent) in 1990?
Your answer should be very brief. 2.22e+05. What is the difference between the highest and the second highest Emissions (1000 metric ton of CO2 equivalent) in 2000?
Make the answer very short. 2.86e+05. What is the difference between the highest and the second highest Emissions (1000 metric ton of CO2 equivalent) of 2005?
Offer a terse response. 3.29e+05. What is the difference between the highest and the second highest Emissions (1000 metric ton of CO2 equivalent) of 2008?
Provide a short and direct response. 3.55e+05. What is the difference between the highest and the lowest Emissions (1000 metric ton of CO2 equivalent) in 1990?
Make the answer very short. 2.52e+05. What is the difference between the highest and the lowest Emissions (1000 metric ton of CO2 equivalent) of 2000?
Provide a short and direct response. 3.02e+05. What is the difference between the highest and the lowest Emissions (1000 metric ton of CO2 equivalent) of 2005?
Make the answer very short. 3.46e+05. What is the difference between the highest and the lowest Emissions (1000 metric ton of CO2 equivalent) in 2008?
Keep it short and to the point. 3.74e+05. 